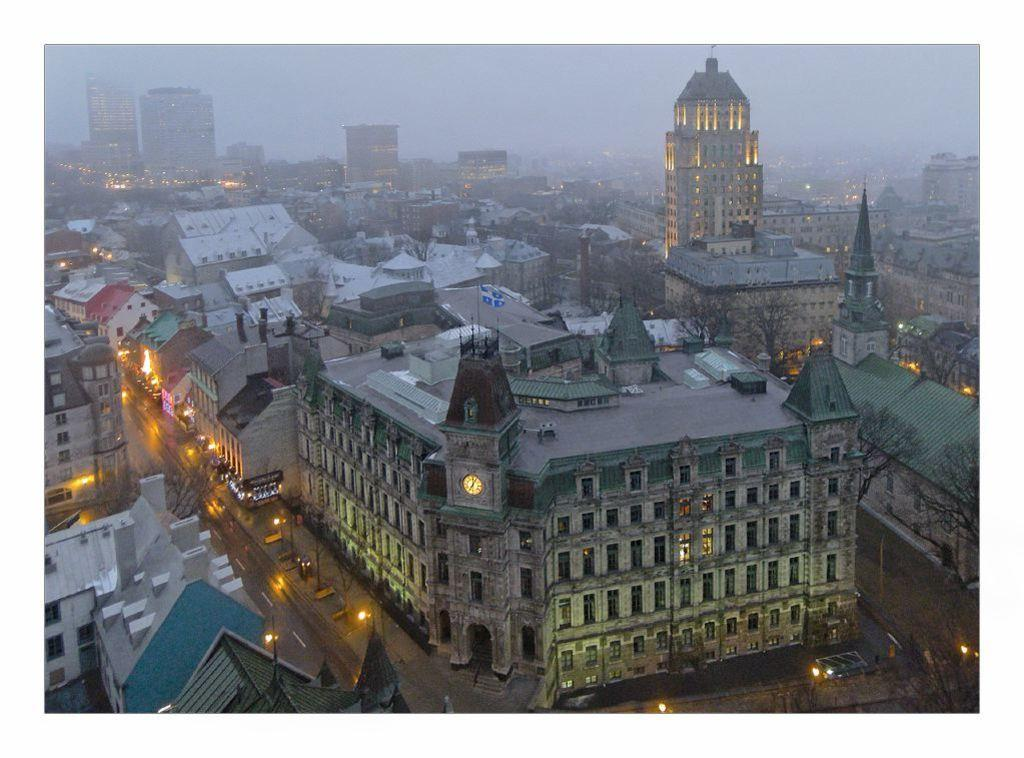What type of structures can be seen in the image? There are buildings in the image. What architectural features are visible on the buildings? There are windows and poles visible on the buildings. What type of vegetation is present in the image? There are trees in the image. What type of illumination is present in the image? There are lights in the image. What part of the natural environment is visible in the image? The sky is visible in the image. What time-related object can be seen in the image? There is a clock attached to a wall in the image. What type of copper material can be seen in the image? There is no copper material present in the image. What type of home is depicted in the image? The image does not depict a home; it shows buildings and other structures. 